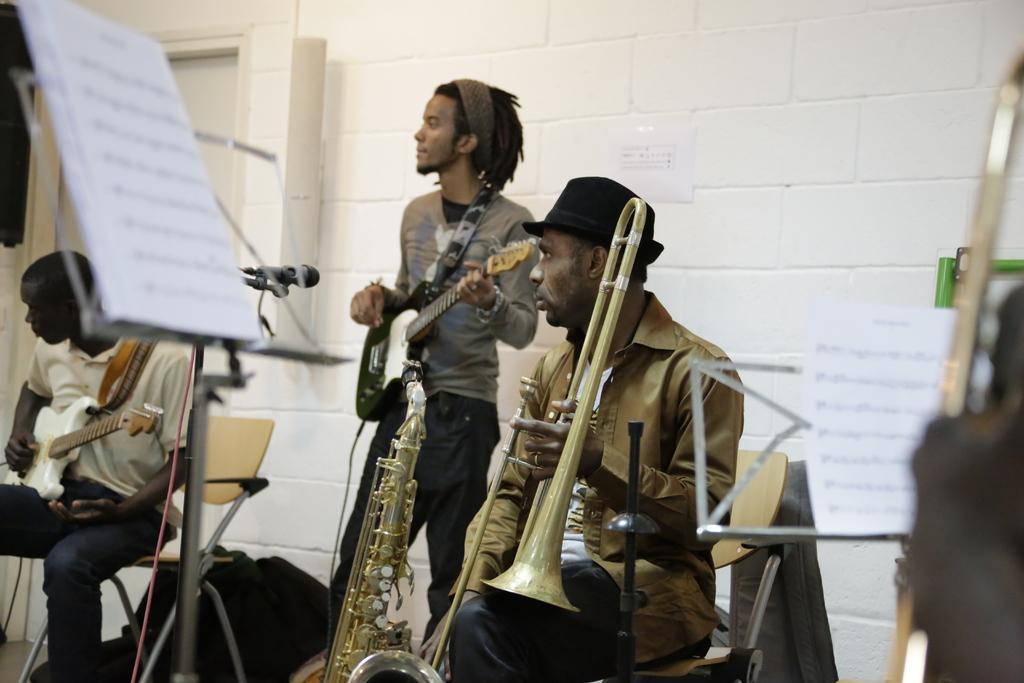How would you summarize this image in a sentence or two? In this picture we can see three men where two are sitting holding guitars, trump in their hands and here man in middle playing guitar and in front of him there is mic and in background we can see wall. 